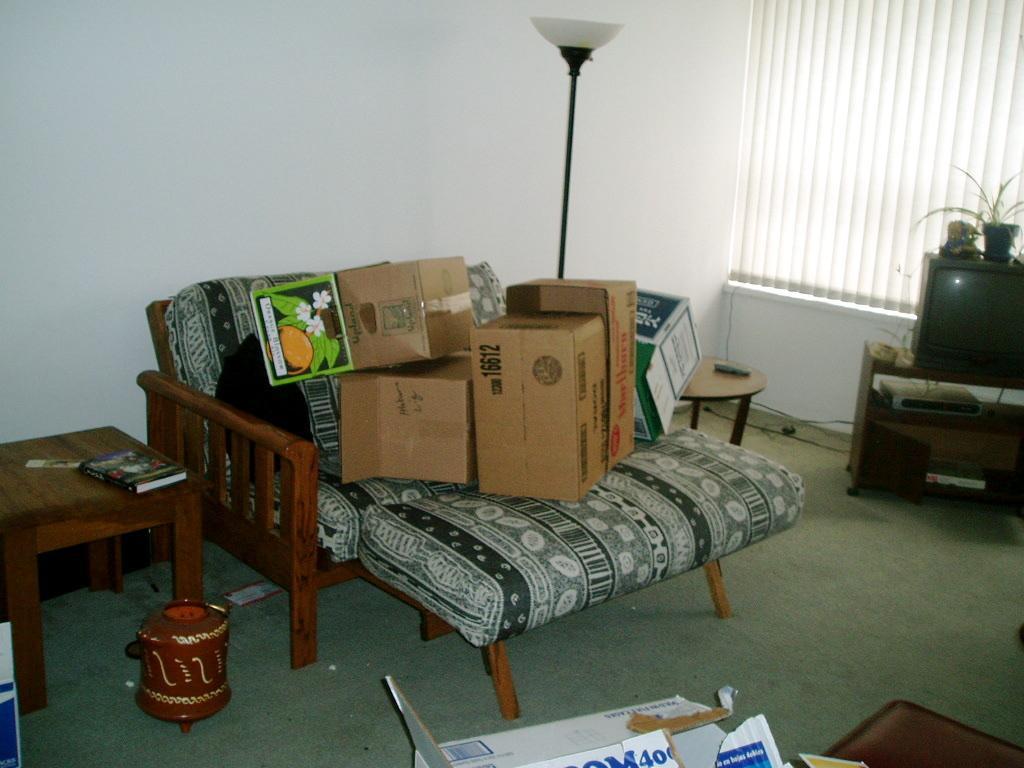In one or two sentences, can you explain what this image depicts? There is a wooden table which is on the left side and a book is kept on it. There is a television on the right side. 